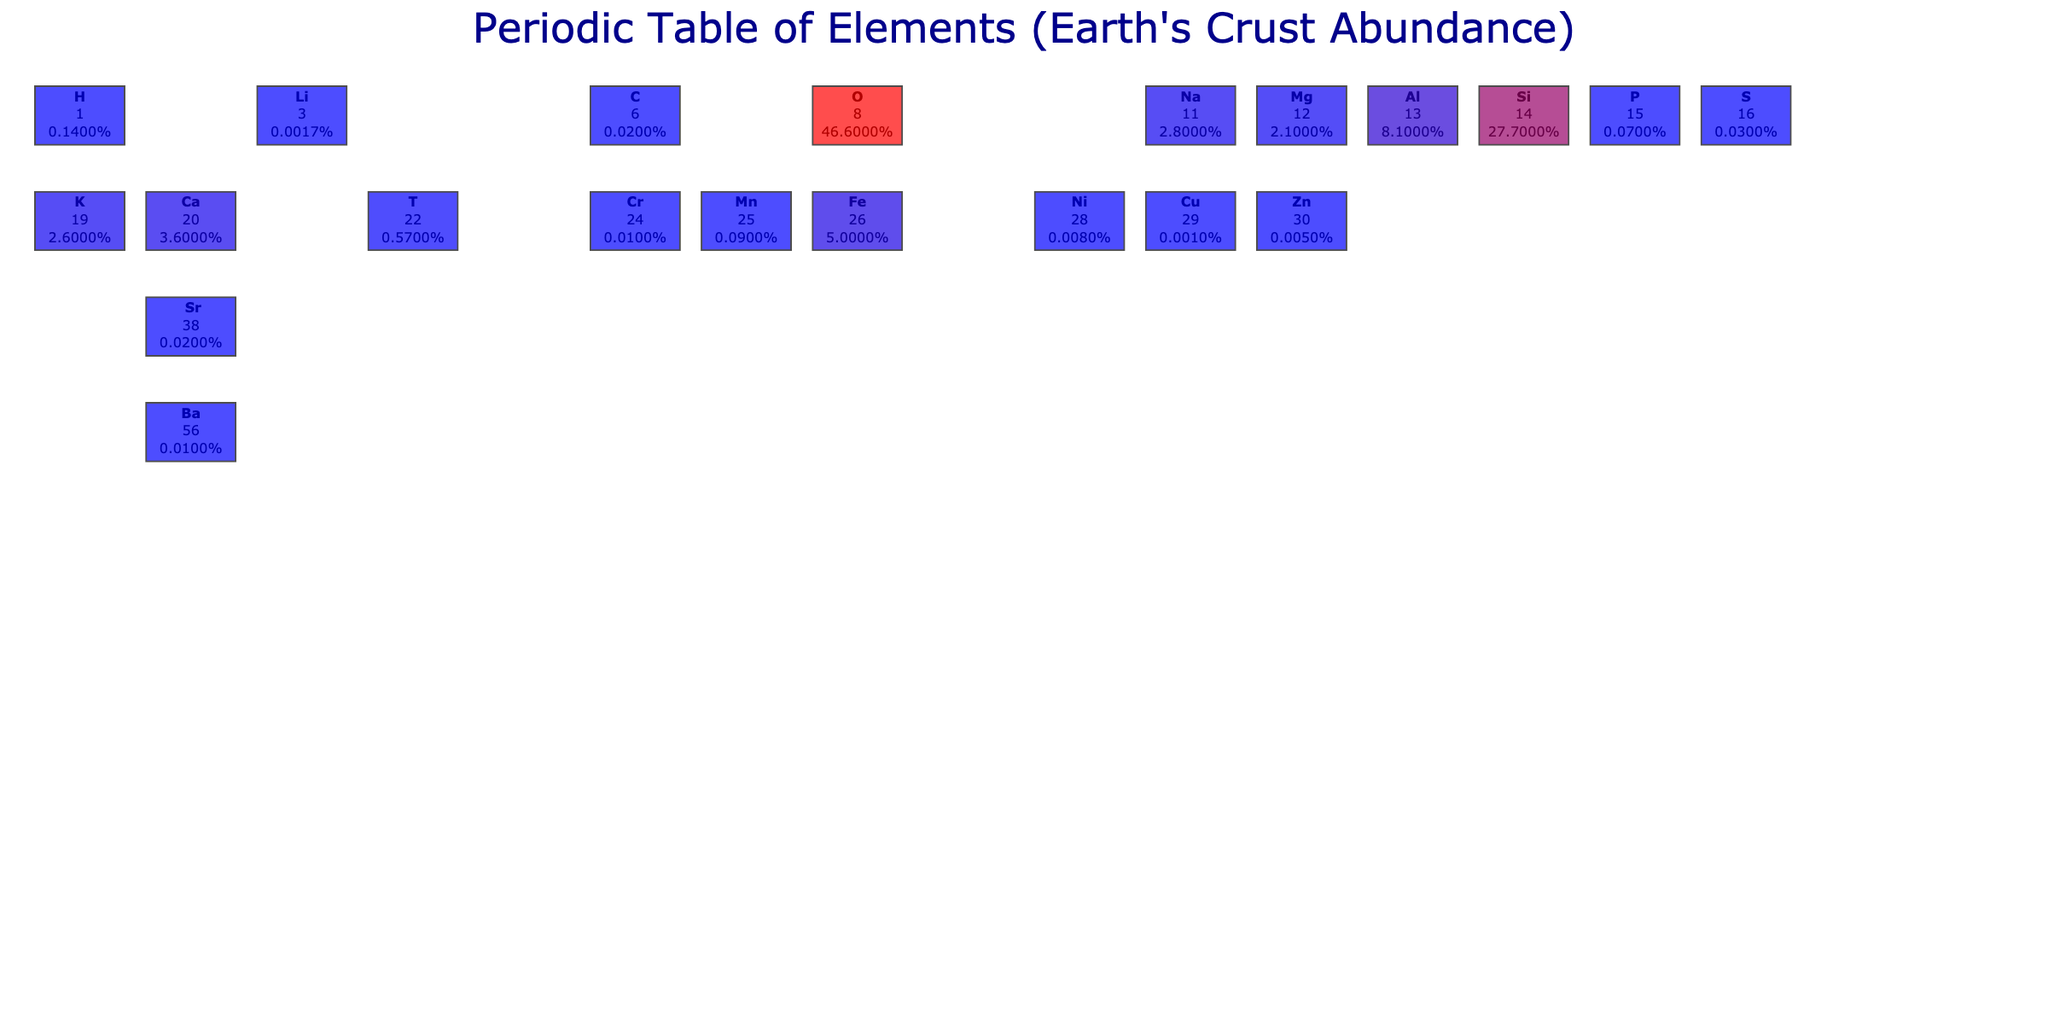What is the atomic number of Silicon? Silicon's atomic number is provided in the table alongside its symbol and other elements. By locating Silicon, we can see its atomic number is 14.
Answer: 14 What percentage of the Earth's crust is made up of Iron? The table indicates the abundance of each element, specifically noting that Iron has an abundance of 5.0% by weight.
Answer: 5.0% Is the abundance of Sodium greater than that of Potassium? According to the table, Sodium has an abundance of 2.8% while Potassium has 2.6%. Since 2.8% is greater than 2.6%, the statement is true.
Answer: Yes What is the total abundance of Aluminum and Magnesium combined? To find the total abundance of Aluminum and Magnesium, we add their individual abundances from the table: Aluminum (8.1%) + Magnesium (2.1%) = 10.2%.
Answer: 10.2% What element has the lowest abundance by weight in the Earth's crust? By reviewing the abundances listed in the table, we can determine that Lithium has the lowest abundance at 0.0017%.
Answer: Lithium What is the average abundance of Oxygen, Silicon, and Aluminum? We first sum the percentages: Oxygen (46.6%) + Silicon (27.7%) + Aluminum (8.1%) = 82.4%. Then we divide by the number of elements (3): 82.4% / 3 = 27.47%.
Answer: 27.47% Do Manganese and Phosphorus have the same abundance in the Earth's crust? The table indicates the abundance of Manganese (0.09%) and Phosphorus (0.07%). Since these values are different, the statement is false.
Answer: No Which two elements have abundances that total more than 50%? We examine pairs of elements to find their combined abundances. Oxygen (46.6%) and Silicon (27.7%) total 74.3%, which exceeds 50%. Therefore, these two elements fit the criteria.
Answer: Oxygen and Silicon If all elements in the table are sorted by abundance, which element is ranked third? Looking at the abundance values, the order from highest to lowest shows that after Oxygen and Silicon, Aluminum is the third most abundant element in the Earth's crust.
Answer: Aluminum 